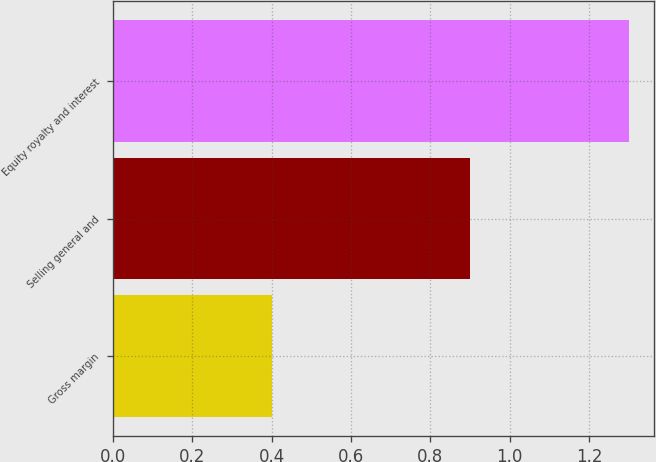Convert chart to OTSL. <chart><loc_0><loc_0><loc_500><loc_500><bar_chart><fcel>Gross margin<fcel>Selling general and<fcel>Equity royalty and interest<nl><fcel>0.4<fcel>0.9<fcel>1.3<nl></chart> 